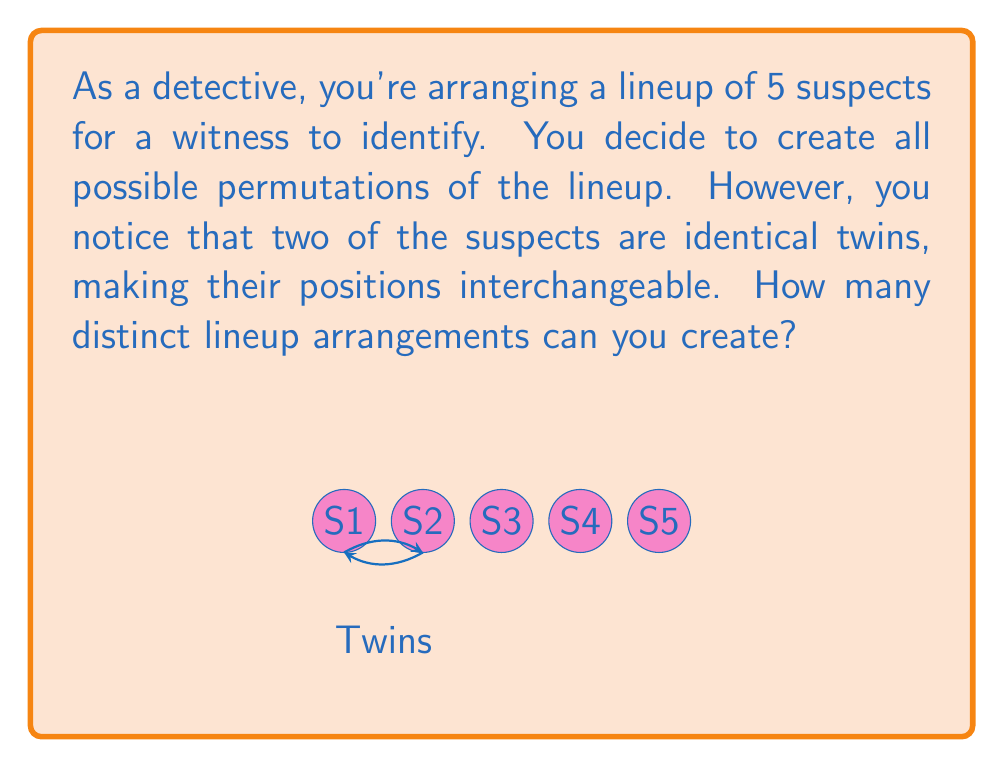What is the answer to this math problem? Let's approach this step-by-step:

1) First, consider the total number of permutations without the twin constraint:
   $$ 5! = 5 \times 4 \times 3 \times 2 \times 1 = 120 $$

2) However, since two suspects are identical twins, their positions are interchangeable. This means that for each arrangement, swapping the twins creates an identical lineup.

3) In permutation group theory, this scenario is equivalent to finding the order of a quotient group. The original group is $S_5$ (all permutations of 5 elements), and we're quotienting by the subgroup that swaps the twins.

4) The number of elements in this subgroup is 2! = 2, as there are two ways to arrange the twins (AB or BA).

5) By the orbit-stabilizer theorem, the number of distinct arrangements is:
   $$ \frac{|S_5|}{|S_2|} = \frac{5!}{2!} $$

6) Calculating this:
   $$ \frac{5!}{2!} = \frac{120}{2} = 60 $$

Therefore, there are 60 distinct lineup arrangements.
Answer: 60 